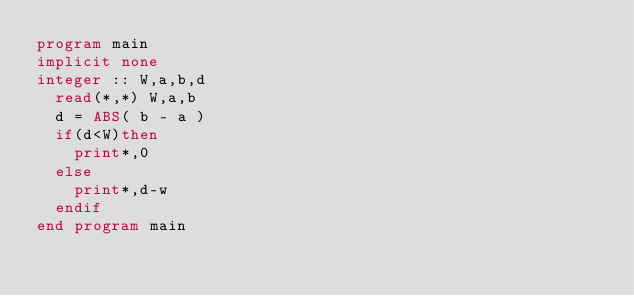<code> <loc_0><loc_0><loc_500><loc_500><_FORTRAN_>program main
implicit none
integer :: W,a,b,d
  read(*,*) W,a,b
  d = ABS( b - a )
  if(d<W)then
    print*,0
  else
    print*,d-w
  endif
end program main
</code> 